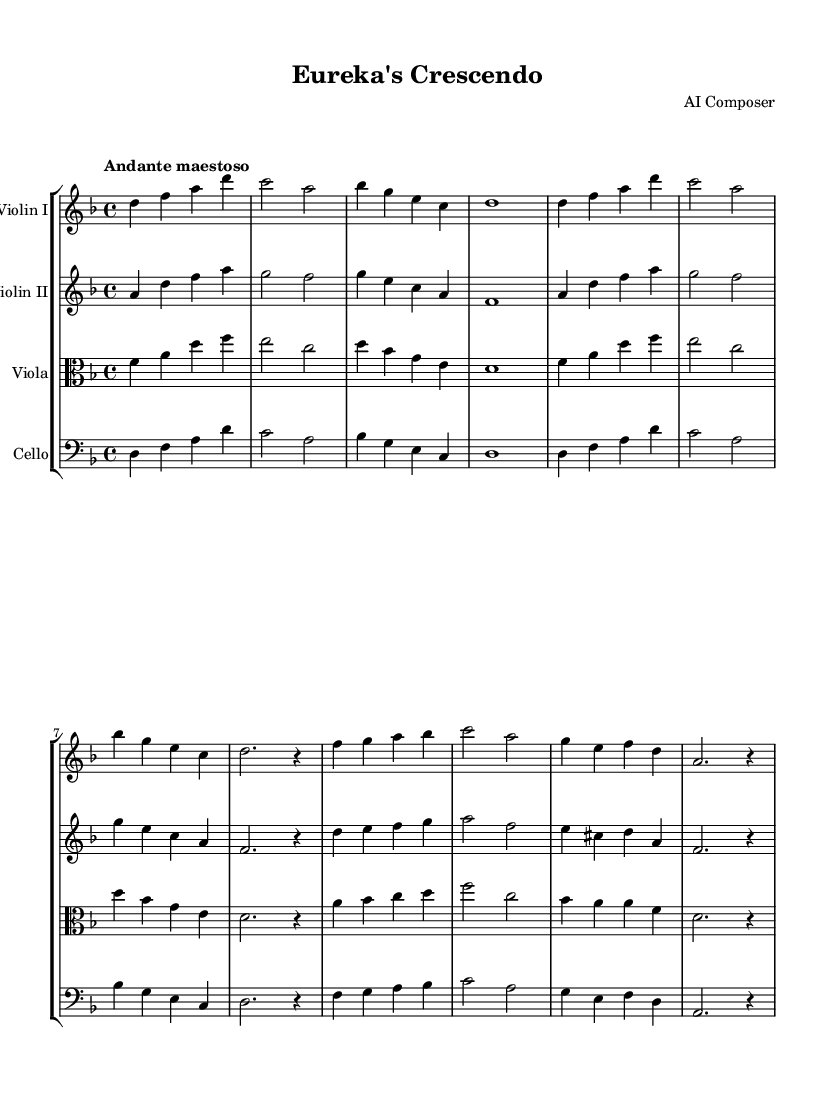What is the key signature of this music? The key signature is D minor, which has one flat (B flat). The note after the key signature indicates the tonic note of the scale.
Answer: D minor What is the time signature of this music? The time signature is indicated at the beginning of the score and shows that there are four beats per measure, with a quarter note receiving one beat.
Answer: 4/4 What is the tempo marking indicated in the sheet music? The tempo marking at the beginning specifies the speed and feel of the piece, which in this case is "Andante maestoso," indicating a slow, majestic tempo.
Answer: Andante maestoso How many measures are in Theme A? To determine the number of measures in Theme A, we count the complete measures notated under the Theme A section. There are four measures visible.
Answer: Four measures What is the highest note played by Violin I in the introduction? Looking at the notes in the Violin I part during the introduction, we find that the highest note is D, which is the first note played. Its pitch is determined by both the note's position on the staff and octave placement.
Answer: D How does the melody in Violin II relate to Violin I in the introduction? By comparing the melodies in Violin I and Violin II, we observe that Violin II plays a simplified version of the background harmony that supporting Violin I's melodic lead. This is common in ensemble pieces where parts complement each other.
Answer: Complementary Which instruments are involved in the score? The score includes four instruments: Violin I, Violin II, Viola, and Cello. This is directly indicated in the score staff group and their respective names.
Answer: Violin I, Violin II, Viola, Cello 